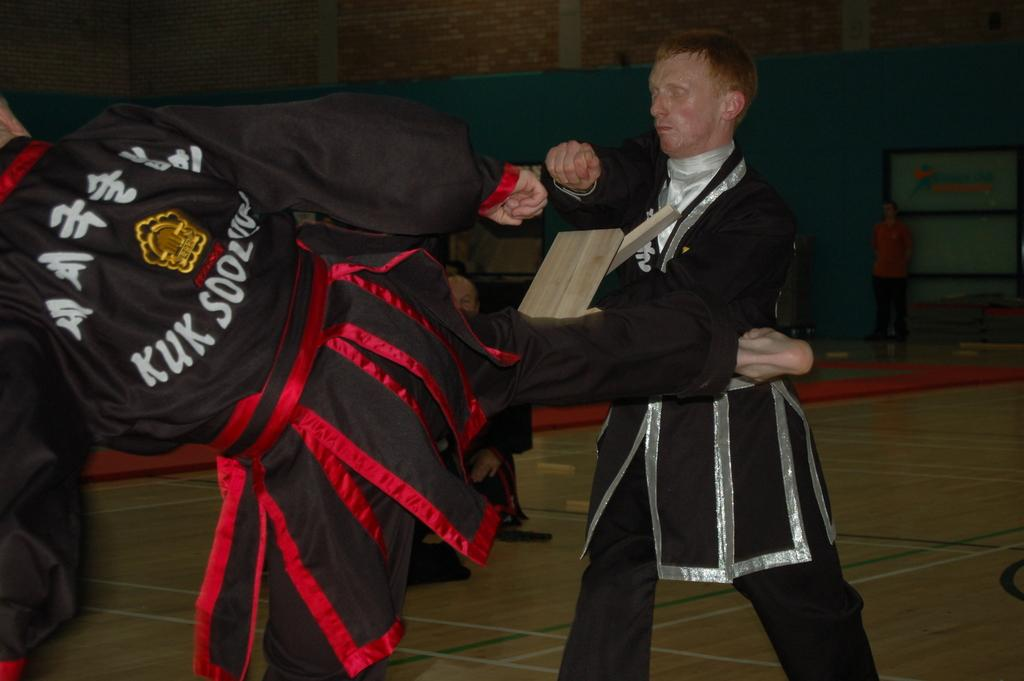<image>
Describe the image concisely. The word KUK is on the back of a man's jacket. 